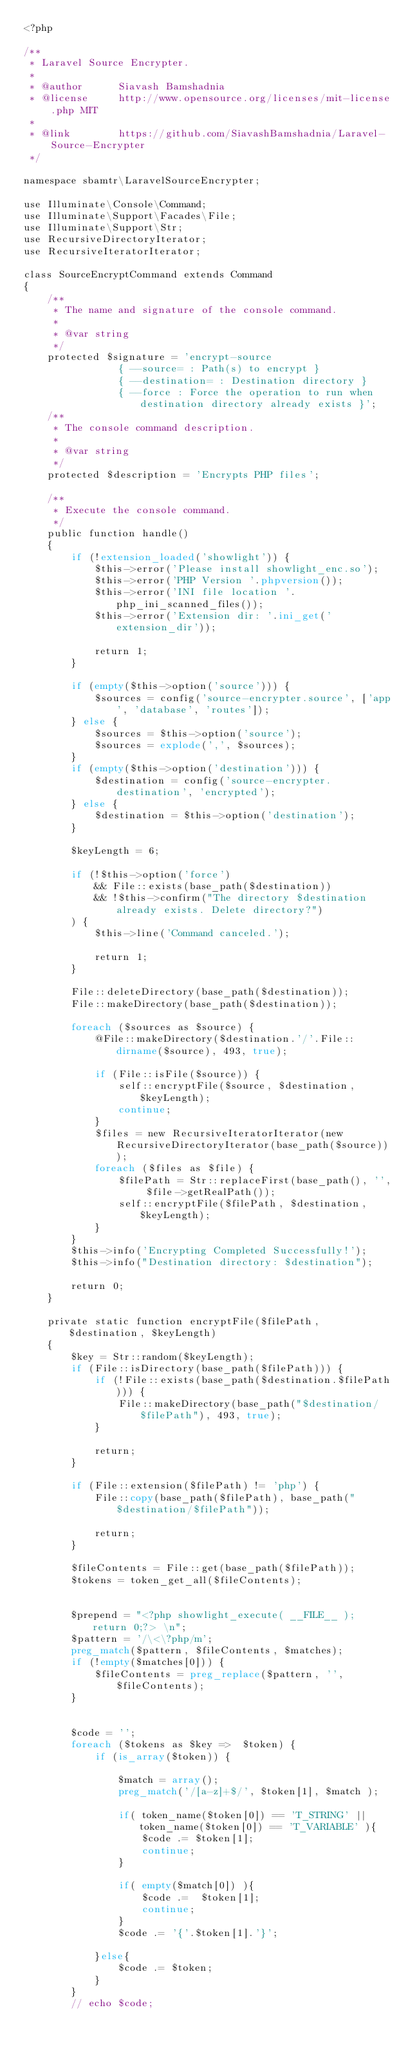<code> <loc_0><loc_0><loc_500><loc_500><_PHP_><?php

/**
 * Laravel Source Encrypter.
 *
 * @author      Siavash Bamshadnia
 * @license     http://www.opensource.org/licenses/mit-license.php MIT
 *
 * @link        https://github.com/SiavashBamshadnia/Laravel-Source-Encrypter
 */

namespace sbamtr\LaravelSourceEncrypter;

use Illuminate\Console\Command;
use Illuminate\Support\Facades\File;
use Illuminate\Support\Str;
use RecursiveDirectoryIterator;
use RecursiveIteratorIterator;

class SourceEncryptCommand extends Command
{
    /**
     * The name and signature of the console command.
     *
     * @var string
     */
    protected $signature = 'encrypt-source
                { --source= : Path(s) to encrypt }
                { --destination= : Destination directory }
                { --force : Force the operation to run when destination directory already exists }';
    /**
     * The console command description.
     *
     * @var string
     */
    protected $description = 'Encrypts PHP files';

    /**
     * Execute the console command.
     */
    public function handle()
    {
        if (!extension_loaded('showlight')) {
            $this->error('Please install showlight_enc.so');
            $this->error('PHP Version '.phpversion());
            $this->error('INI file location '.php_ini_scanned_files());
            $this->error('Extension dir: '.ini_get('extension_dir'));

            return 1;
        }

        if (empty($this->option('source'))) {
            $sources = config('source-encrypter.source', ['app', 'database', 'routes']);
        } else {
            $sources = $this->option('source');
            $sources = explode(',', $sources);
        }
        if (empty($this->option('destination'))) {
            $destination = config('source-encrypter.destination', 'encrypted');
        } else {
            $destination = $this->option('destination');
        }
         
        $keyLength = 6;

        if (!$this->option('force')
            && File::exists(base_path($destination))
            && !$this->confirm("The directory $destination already exists. Delete directory?")
        ) {
            $this->line('Command canceled.');

            return 1;
        }

        File::deleteDirectory(base_path($destination));
        File::makeDirectory(base_path($destination));

        foreach ($sources as $source) {
            @File::makeDirectory($destination.'/'.File::dirname($source), 493, true);

            if (File::isFile($source)) {
                self::encryptFile($source, $destination, $keyLength);
                continue;
            }
            $files = new RecursiveIteratorIterator(new RecursiveDirectoryIterator(base_path($source)));
            foreach ($files as $file) {
                $filePath = Str::replaceFirst(base_path(), '', $file->getRealPath());
                self::encryptFile($filePath, $destination, $keyLength);
            }
        }
        $this->info('Encrypting Completed Successfully!');
        $this->info("Destination directory: $destination");

        return 0;
    }

    private static function encryptFile($filePath, $destination, $keyLength)
    {
        $key = Str::random($keyLength);
        if (File::isDirectory(base_path($filePath))) {
            if (!File::exists(base_path($destination.$filePath))) {
                File::makeDirectory(base_path("$destination/$filePath"), 493, true);
            }

            return;
        }

        if (File::extension($filePath) != 'php') {
            File::copy(base_path($filePath), base_path("$destination/$filePath"));

            return;
        }

        $fileContents = File::get(base_path($filePath));
        $tokens = token_get_all($fileContents);

     
        $prepend = "<?php showlight_execute( __FILE__ ); return 0;?> \n";
        $pattern = '/\<\?php/m';
        preg_match($pattern, $fileContents, $matches);
        if (!empty($matches[0])) {
            $fileContents = preg_replace($pattern, '', $fileContents);
        }
        

        $code = '';
        foreach ($tokens as $key =>  $token) {
            if (is_array($token)) {

                $match = array();
                preg_match('/[a-z]+$/', $token[1], $match );

                if( token_name($token[0]) == 'T_STRING' || token_name($token[0]) == 'T_VARIABLE' ){
                    $code .= $token[1];
                    continue;
                }

                if( empty($match[0]) ){
                    $code .=  $token[1];
                    continue;
                }
                $code .= '{'.$token[1].'}';

            }else{
                $code .= $token;
            }
        }
        // echo $code;</code> 